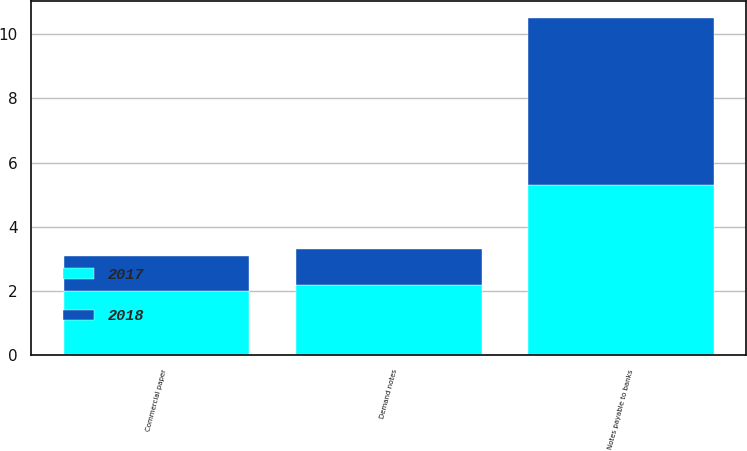Convert chart to OTSL. <chart><loc_0><loc_0><loc_500><loc_500><stacked_bar_chart><ecel><fcel>Notes payable to banks<fcel>Commercial paper<fcel>Demand notes<nl><fcel>2017<fcel>5.3<fcel>2<fcel>2.2<nl><fcel>2018<fcel>5.2<fcel>1.1<fcel>1.1<nl></chart> 